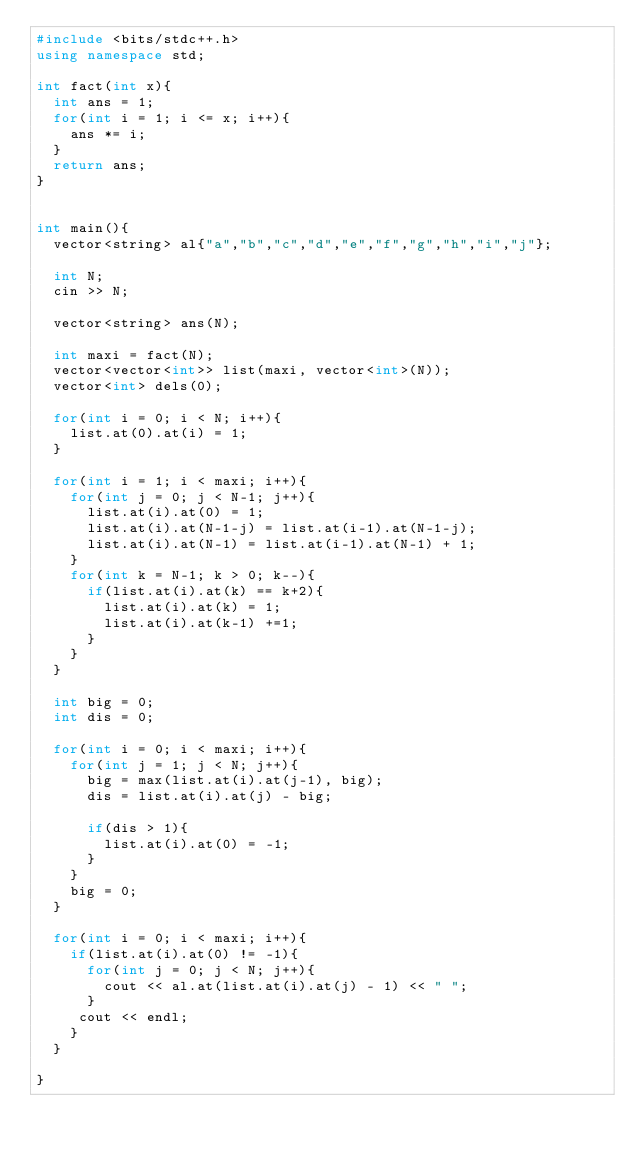<code> <loc_0><loc_0><loc_500><loc_500><_C++_>#include <bits/stdc++.h>
using namespace std;

int fact(int x){
  int ans = 1;
  for(int i = 1; i <= x; i++){
    ans *= i;
  }
  return ans;
}


int main(){
  vector<string> al{"a","b","c","d","e","f","g","h","i","j"};
  
  int N;
  cin >> N;
  
  vector<string> ans(N);
  
  int maxi = fact(N);
  vector<vector<int>> list(maxi, vector<int>(N));
  vector<int> dels(0);
  
  for(int i = 0; i < N; i++){
    list.at(0).at(i) = 1;
  }

  for(int i = 1; i < maxi; i++){
    for(int j = 0; j < N-1; j++){
      list.at(i).at(0) = 1;
      list.at(i).at(N-1-j) = list.at(i-1).at(N-1-j);
      list.at(i).at(N-1) = list.at(i-1).at(N-1) + 1;
    }
    for(int k = N-1; k > 0; k--){
      if(list.at(i).at(k) == k+2){
        list.at(i).at(k) = 1;
        list.at(i).at(k-1) +=1;
      }  
    }
  }
  
  int big = 0;
  int dis = 0;
  
  for(int i = 0; i < maxi; i++){
    for(int j = 1; j < N; j++){
      big = max(list.at(i).at(j-1), big);
      dis = list.at(i).at(j) - big;
      
      if(dis > 1){
        list.at(i).at(0) = -1;
      }
    }
    big = 0;
  }
  
  for(int i = 0; i < maxi; i++){
    if(list.at(i).at(0) != -1){
      for(int j = 0; j < N; j++){
      	cout << al.at(list.at(i).at(j) - 1) << " ";
      }
     cout << endl;     
    }
  }

}</code> 